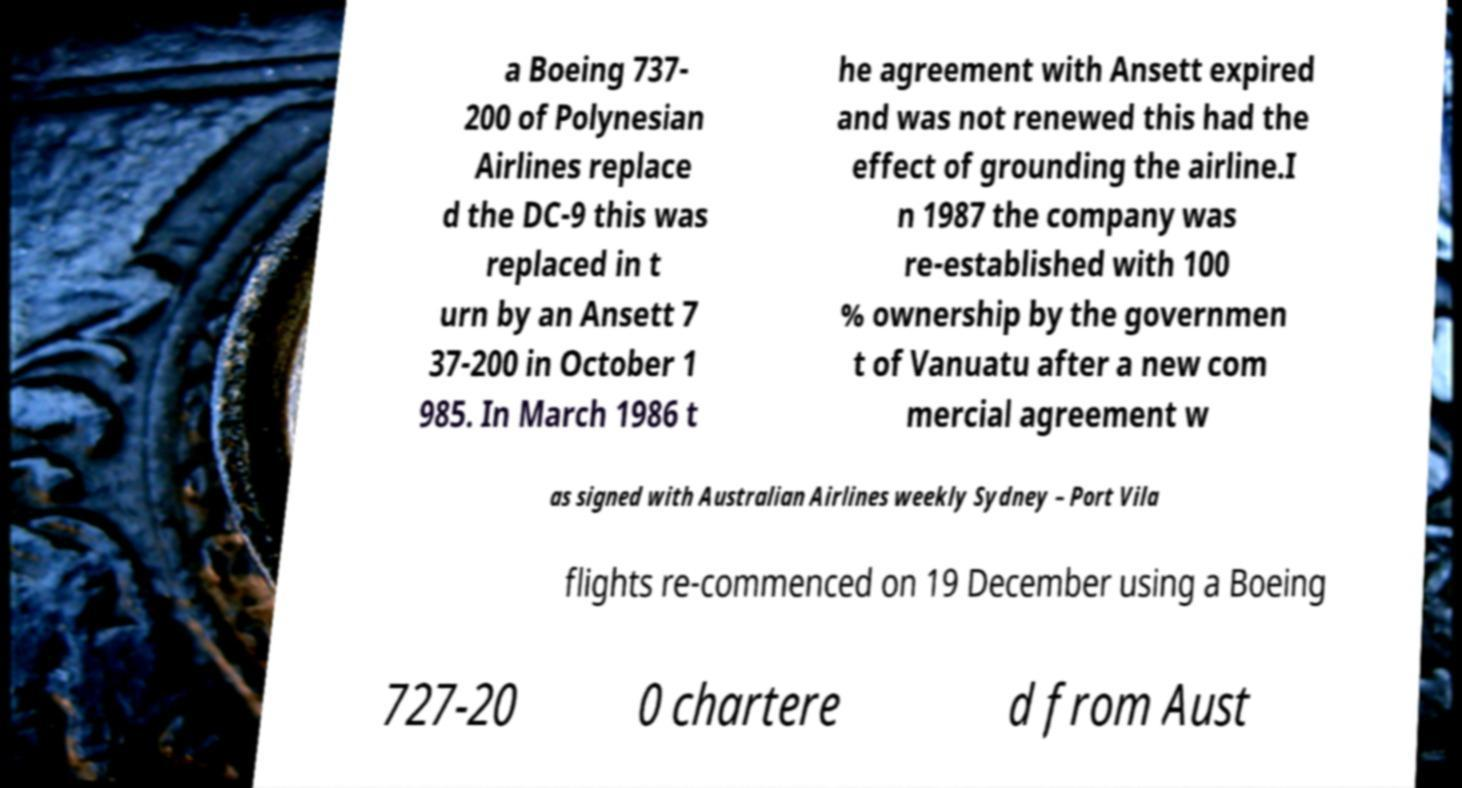Please read and relay the text visible in this image. What does it say? a Boeing 737- 200 of Polynesian Airlines replace d the DC-9 this was replaced in t urn by an Ansett 7 37-200 in October 1 985. In March 1986 t he agreement with Ansett expired and was not renewed this had the effect of grounding the airline.I n 1987 the company was re-established with 100 % ownership by the governmen t of Vanuatu after a new com mercial agreement w as signed with Australian Airlines weekly Sydney – Port Vila flights re-commenced on 19 December using a Boeing 727-20 0 chartere d from Aust 